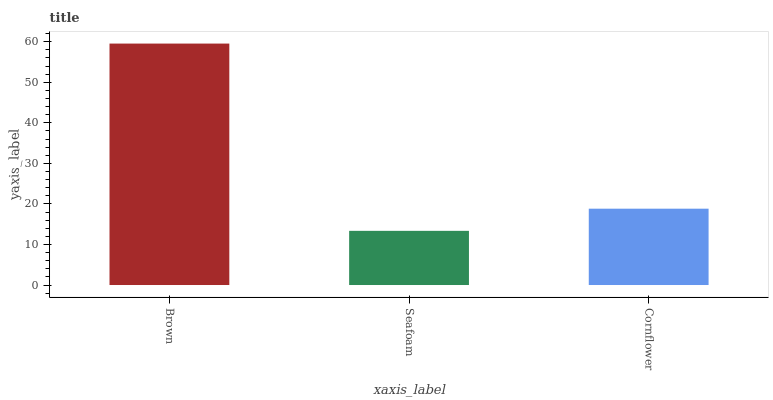Is Seafoam the minimum?
Answer yes or no. Yes. Is Brown the maximum?
Answer yes or no. Yes. Is Cornflower the minimum?
Answer yes or no. No. Is Cornflower the maximum?
Answer yes or no. No. Is Cornflower greater than Seafoam?
Answer yes or no. Yes. Is Seafoam less than Cornflower?
Answer yes or no. Yes. Is Seafoam greater than Cornflower?
Answer yes or no. No. Is Cornflower less than Seafoam?
Answer yes or no. No. Is Cornflower the high median?
Answer yes or no. Yes. Is Cornflower the low median?
Answer yes or no. Yes. Is Brown the high median?
Answer yes or no. No. Is Seafoam the low median?
Answer yes or no. No. 